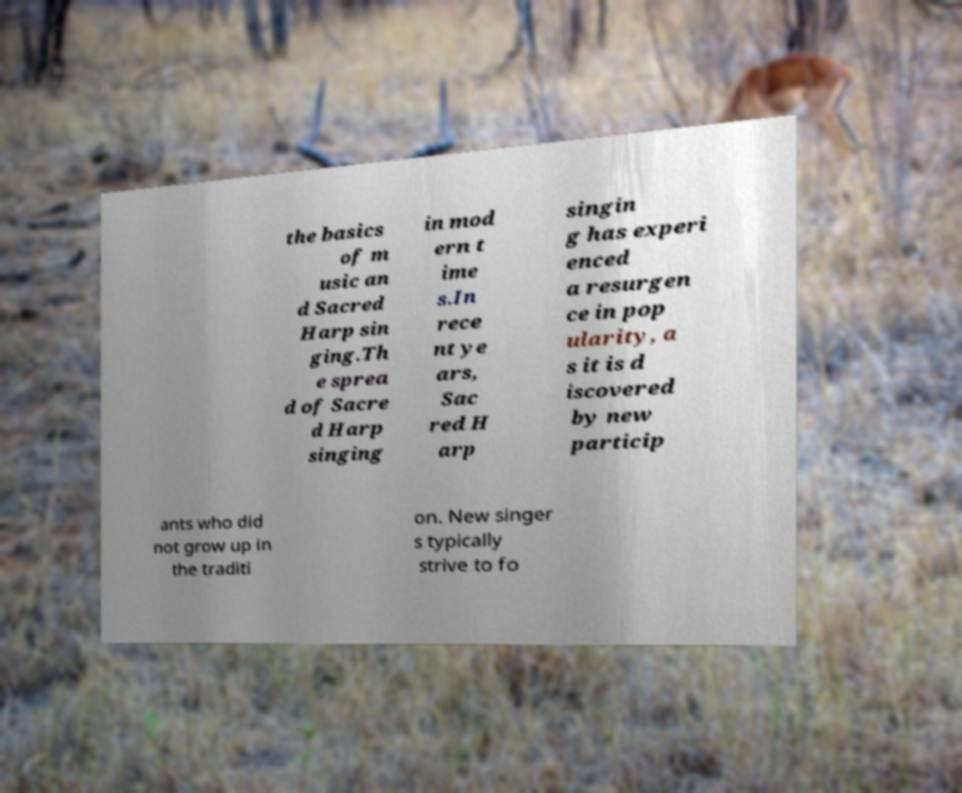Can you read and provide the text displayed in the image?This photo seems to have some interesting text. Can you extract and type it out for me? the basics of m usic an d Sacred Harp sin ging.Th e sprea d of Sacre d Harp singing in mod ern t ime s.In rece nt ye ars, Sac red H arp singin g has experi enced a resurgen ce in pop ularity, a s it is d iscovered by new particip ants who did not grow up in the traditi on. New singer s typically strive to fo 